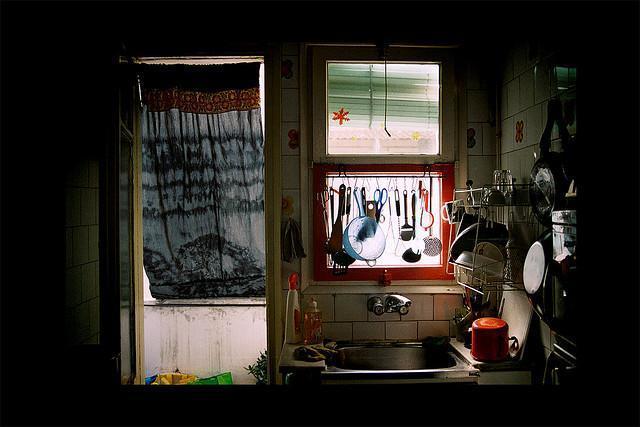How many men do you see?
Give a very brief answer. 0. 